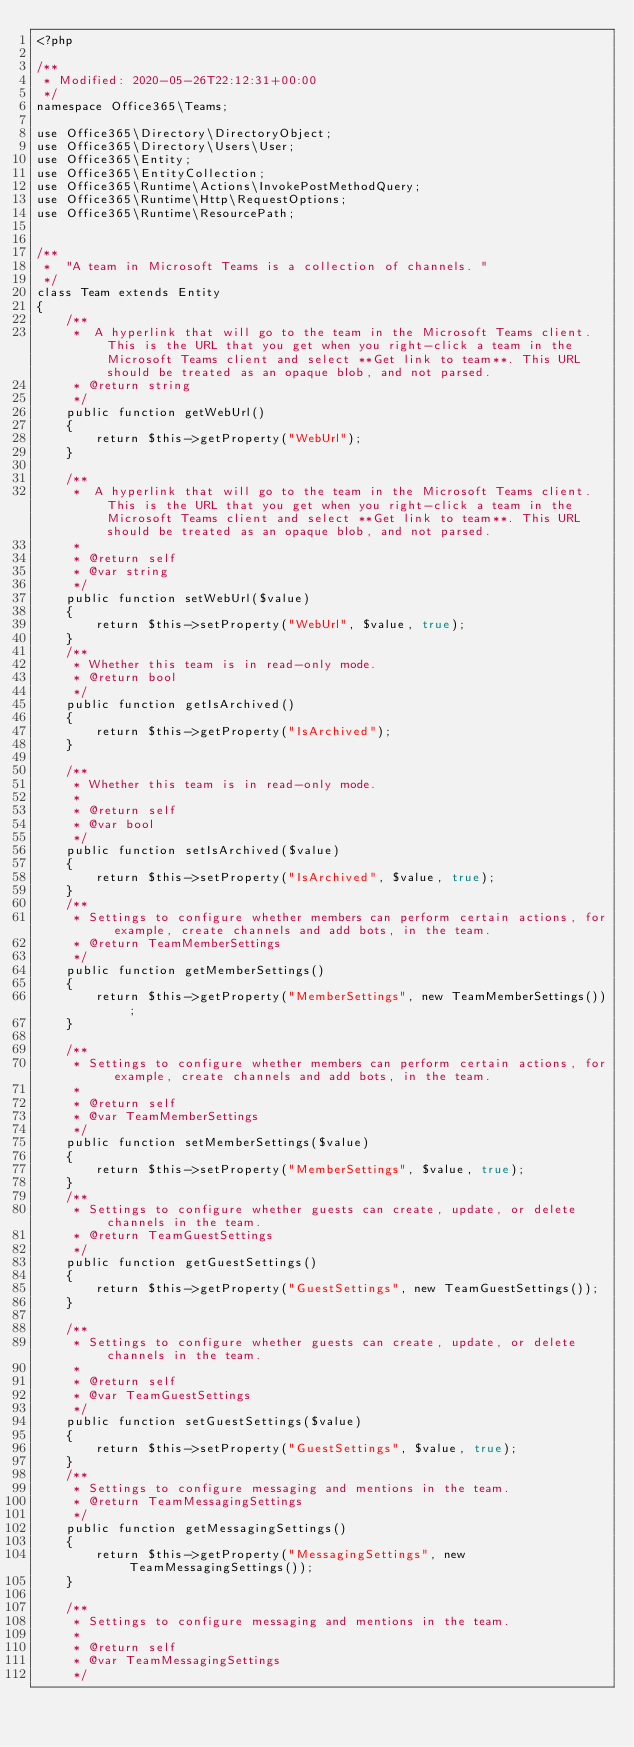<code> <loc_0><loc_0><loc_500><loc_500><_PHP_><?php

/**
 * Modified: 2020-05-26T22:12:31+00:00 
 */
namespace Office365\Teams;

use Office365\Directory\DirectoryObject;
use Office365\Directory\Users\User;
use Office365\Entity;
use Office365\EntityCollection;
use Office365\Runtime\Actions\InvokePostMethodQuery;
use Office365\Runtime\Http\RequestOptions;
use Office365\Runtime\ResourcePath;


/**
 *  "A team in Microsoft Teams is a collection of channels. "
 */
class Team extends Entity
{
    /**
     *  A hyperlink that will go to the team in the Microsoft Teams client. This is the URL that you get when you right-click a team in the Microsoft Teams client and select **Get link to team**. This URL should be treated as an opaque blob, and not parsed. 
     * @return string
     */
    public function getWebUrl()
    {
        return $this->getProperty("WebUrl");
    }

    /**
     *  A hyperlink that will go to the team in the Microsoft Teams client. This is the URL that you get when you right-click a team in the Microsoft Teams client and select **Get link to team**. This URL should be treated as an opaque blob, and not parsed.
     *
     * @return self
     * @var string
     */
    public function setWebUrl($value)
    {
        return $this->setProperty("WebUrl", $value, true);
    }
    /**
     * Whether this team is in read-only mode. 
     * @return bool
     */
    public function getIsArchived()
    {
        return $this->getProperty("IsArchived");
    }

    /**
     * Whether this team is in read-only mode.
     *
     * @return self
     * @var bool
     */
    public function setIsArchived($value)
    {
        return $this->setProperty("IsArchived", $value, true);
    }
    /**
     * Settings to configure whether members can perform certain actions, for example, create channels and add bots, in the team.
     * @return TeamMemberSettings
     */
    public function getMemberSettings()
    {
        return $this->getProperty("MemberSettings", new TeamMemberSettings());
    }

    /**
     * Settings to configure whether members can perform certain actions, for example, create channels and add bots, in the team.
     *
     * @return self
     * @var TeamMemberSettings
     */
    public function setMemberSettings($value)
    {
        return $this->setProperty("MemberSettings", $value, true);
    }
    /**
     * Settings to configure whether guests can create, update, or delete channels in the team.
     * @return TeamGuestSettings
     */
    public function getGuestSettings()
    {
        return $this->getProperty("GuestSettings", new TeamGuestSettings());
    }

    /**
     * Settings to configure whether guests can create, update, or delete channels in the team.
     *
     * @return self
     * @var TeamGuestSettings
     */
    public function setGuestSettings($value)
    {
        return $this->setProperty("GuestSettings", $value, true);
    }
    /**
     * Settings to configure messaging and mentions in the team.
     * @return TeamMessagingSettings
     */
    public function getMessagingSettings()
    {
        return $this->getProperty("MessagingSettings", new TeamMessagingSettings());
    }

    /**
     * Settings to configure messaging and mentions in the team.
     *
     * @return self
     * @var TeamMessagingSettings
     */</code> 